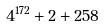Convert formula to latex. <formula><loc_0><loc_0><loc_500><loc_500>4 ^ { 1 7 2 } + 2 + 2 5 8</formula> 